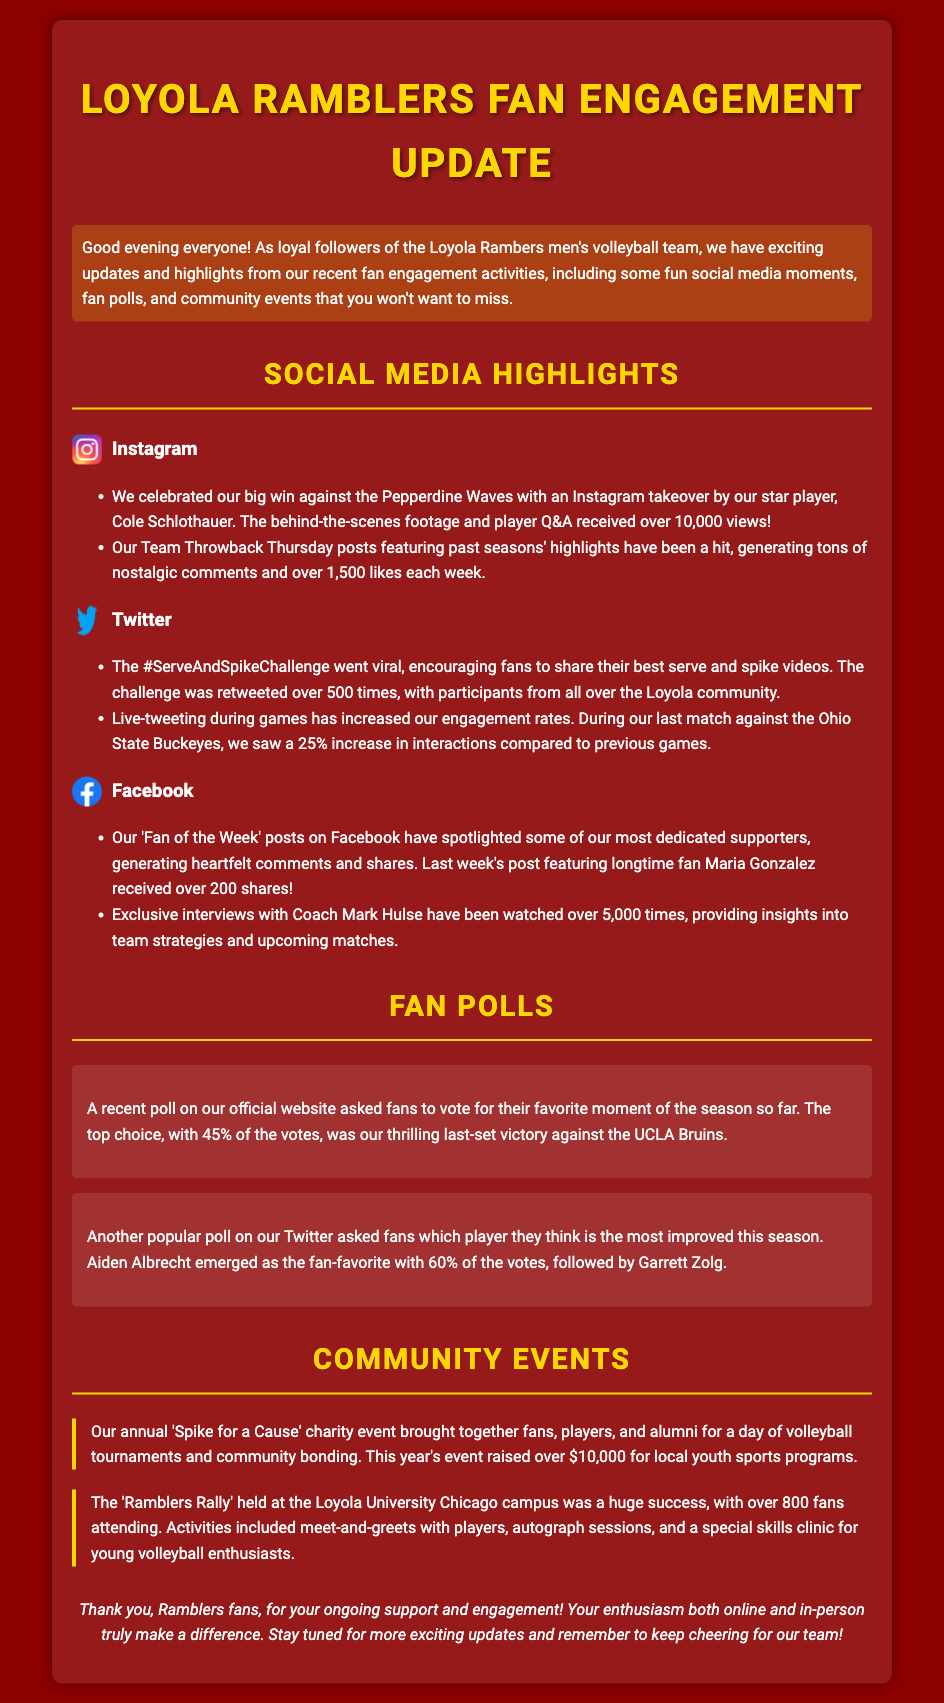what was the Instagram takeover about? The Instagram takeover was by star player Cole Schlothauer celebrating a big win against the Pepperdine Waves.
Answer: Cole Schlothauer how many views did Cole Schlothauer's Instagram takeover receive? The Instagram takeover received over 10,000 views.
Answer: over 10,000 views what was the top choice in the recent fan poll about favorite moment? The top choice in the fan poll was the thrilling last-set victory against the UCLA Bruins.
Answer: last-set victory against the UCLA Bruins how much money did the 'Spike for a Cause' charity event raise? The charity event raised over $10,000 for local youth sports programs.
Answer: over $10,000 how many fans attended the 'Ramblers Rally'? The 'Ramblers Rally' had over 800 fans attending.
Answer: over 800 fans which player emerged as the most improved according to a Twitter poll? Aiden Albrecht emerged as the fan-favorite for most improved player.
Answer: Aiden Albrecht what type of events were included in the 'Ramblers Rally'? The 'Ramblers Rally' included meet-and-greets, autograph sessions, and a skills clinic.
Answer: meet-and-greets, autograph sessions, skills clinic how often does the Team Throwback Thursday post generate likes? The post generates over 1,500 likes each week.
Answer: over 1,500 likes each week what was highlighted in the 'Fan of the Week' posts on Facebook? The 'Fan of the Week' posts spotlight some of the most dedicated supporters.
Answer: dedicated supporters 